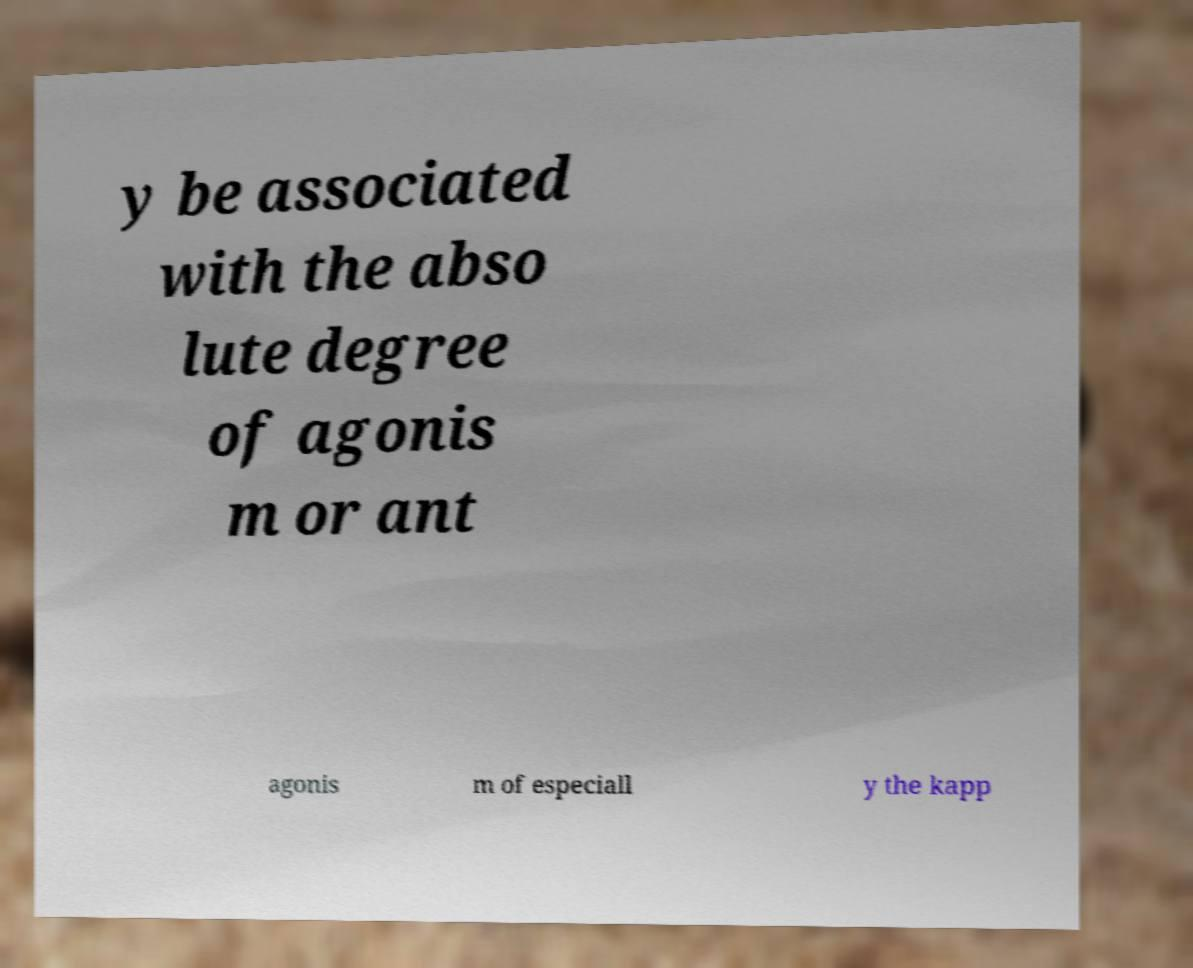Could you assist in decoding the text presented in this image and type it out clearly? y be associated with the abso lute degree of agonis m or ant agonis m of especiall y the kapp 